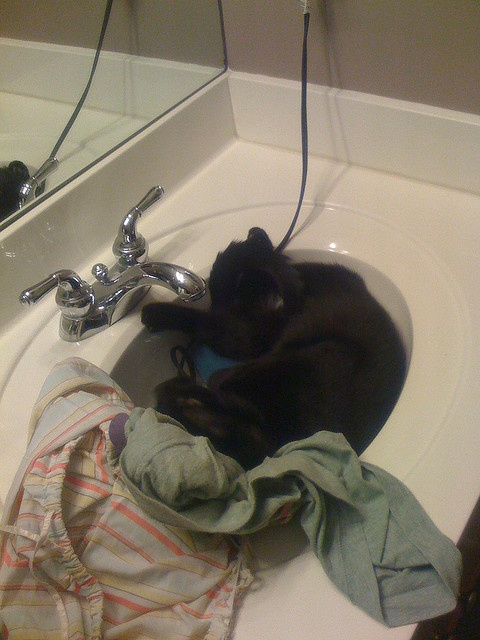Describe the objects in this image and their specific colors. I can see sink in gray and tan tones, cat in gray and black tones, and hair drier in black, darkblue, and gray tones in this image. 